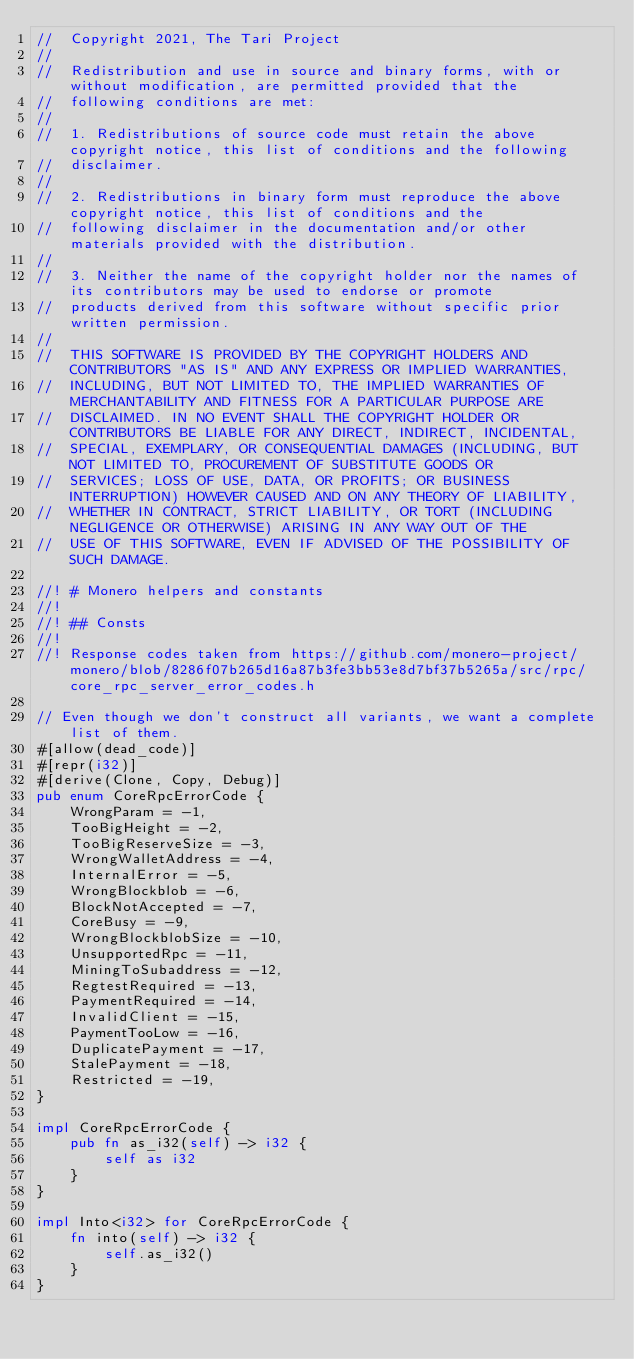<code> <loc_0><loc_0><loc_500><loc_500><_Rust_>//  Copyright 2021, The Tari Project
//
//  Redistribution and use in source and binary forms, with or without modification, are permitted provided that the
//  following conditions are met:
//
//  1. Redistributions of source code must retain the above copyright notice, this list of conditions and the following
//  disclaimer.
//
//  2. Redistributions in binary form must reproduce the above copyright notice, this list of conditions and the
//  following disclaimer in the documentation and/or other materials provided with the distribution.
//
//  3. Neither the name of the copyright holder nor the names of its contributors may be used to endorse or promote
//  products derived from this software without specific prior written permission.
//
//  THIS SOFTWARE IS PROVIDED BY THE COPYRIGHT HOLDERS AND CONTRIBUTORS "AS IS" AND ANY EXPRESS OR IMPLIED WARRANTIES,
//  INCLUDING, BUT NOT LIMITED TO, THE IMPLIED WARRANTIES OF MERCHANTABILITY AND FITNESS FOR A PARTICULAR PURPOSE ARE
//  DISCLAIMED. IN NO EVENT SHALL THE COPYRIGHT HOLDER OR CONTRIBUTORS BE LIABLE FOR ANY DIRECT, INDIRECT, INCIDENTAL,
//  SPECIAL, EXEMPLARY, OR CONSEQUENTIAL DAMAGES (INCLUDING, BUT NOT LIMITED TO, PROCUREMENT OF SUBSTITUTE GOODS OR
//  SERVICES; LOSS OF USE, DATA, OR PROFITS; OR BUSINESS INTERRUPTION) HOWEVER CAUSED AND ON ANY THEORY OF LIABILITY,
//  WHETHER IN CONTRACT, STRICT LIABILITY, OR TORT (INCLUDING NEGLIGENCE OR OTHERWISE) ARISING IN ANY WAY OUT OF THE
//  USE OF THIS SOFTWARE, EVEN IF ADVISED OF THE POSSIBILITY OF SUCH DAMAGE.

//! # Monero helpers and constants
//!
//! ## Consts
//!
//! Response codes taken from https://github.com/monero-project/monero/blob/8286f07b265d16a87b3fe3bb53e8d7bf37b5265a/src/rpc/core_rpc_server_error_codes.h

// Even though we don't construct all variants, we want a complete list of them.
#[allow(dead_code)]
#[repr(i32)]
#[derive(Clone, Copy, Debug)]
pub enum CoreRpcErrorCode {
    WrongParam = -1,
    TooBigHeight = -2,
    TooBigReserveSize = -3,
    WrongWalletAddress = -4,
    InternalError = -5,
    WrongBlockblob = -6,
    BlockNotAccepted = -7,
    CoreBusy = -9,
    WrongBlockblobSize = -10,
    UnsupportedRpc = -11,
    MiningToSubaddress = -12,
    RegtestRequired = -13,
    PaymentRequired = -14,
    InvalidClient = -15,
    PaymentTooLow = -16,
    DuplicatePayment = -17,
    StalePayment = -18,
    Restricted = -19,
}

impl CoreRpcErrorCode {
    pub fn as_i32(self) -> i32 {
        self as i32
    }
}

impl Into<i32> for CoreRpcErrorCode {
    fn into(self) -> i32 {
        self.as_i32()
    }
}
</code> 